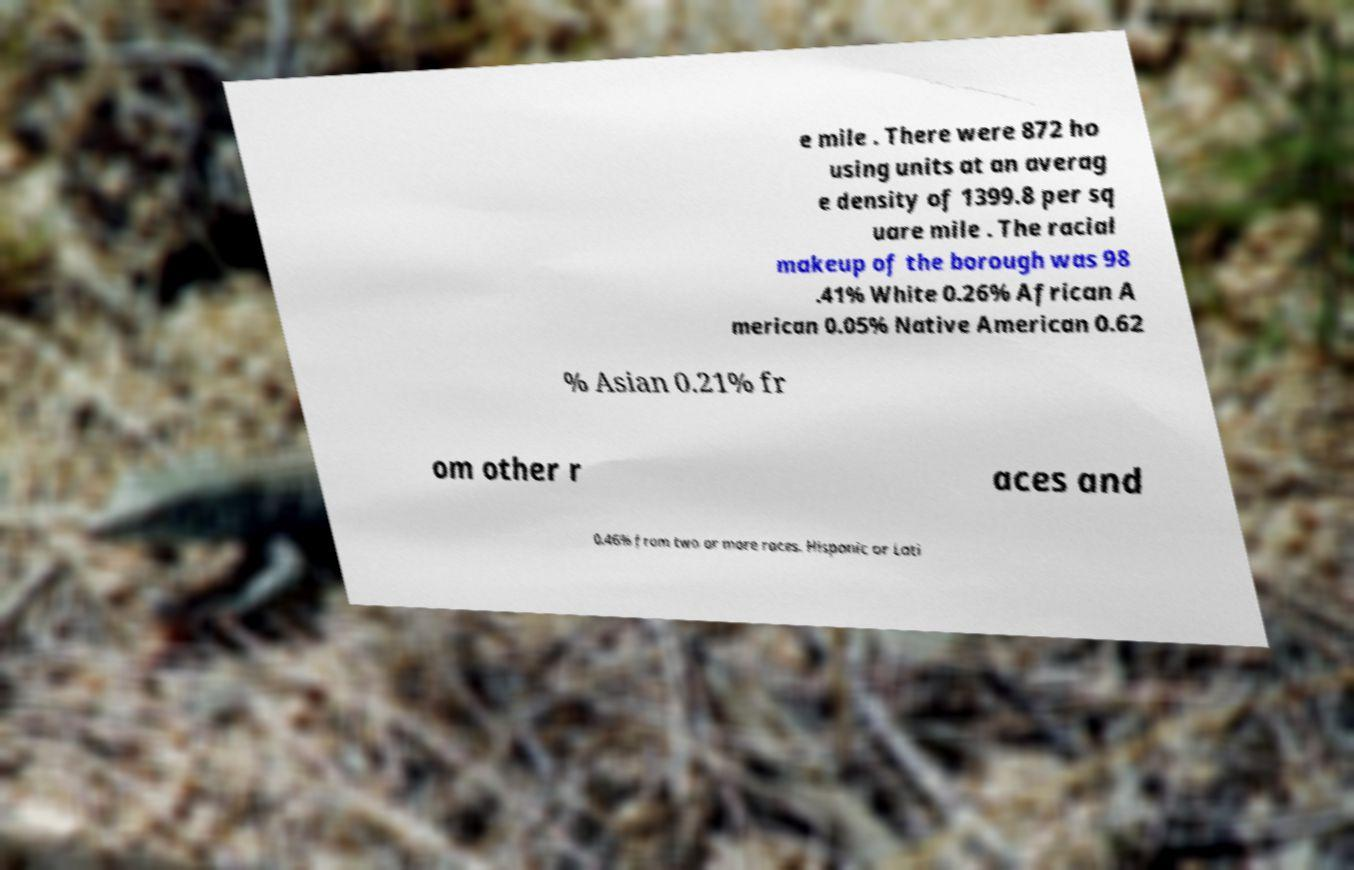Can you read and provide the text displayed in the image?This photo seems to have some interesting text. Can you extract and type it out for me? e mile . There were 872 ho using units at an averag e density of 1399.8 per sq uare mile . The racial makeup of the borough was 98 .41% White 0.26% African A merican 0.05% Native American 0.62 % Asian 0.21% fr om other r aces and 0.46% from two or more races. Hispanic or Lati 